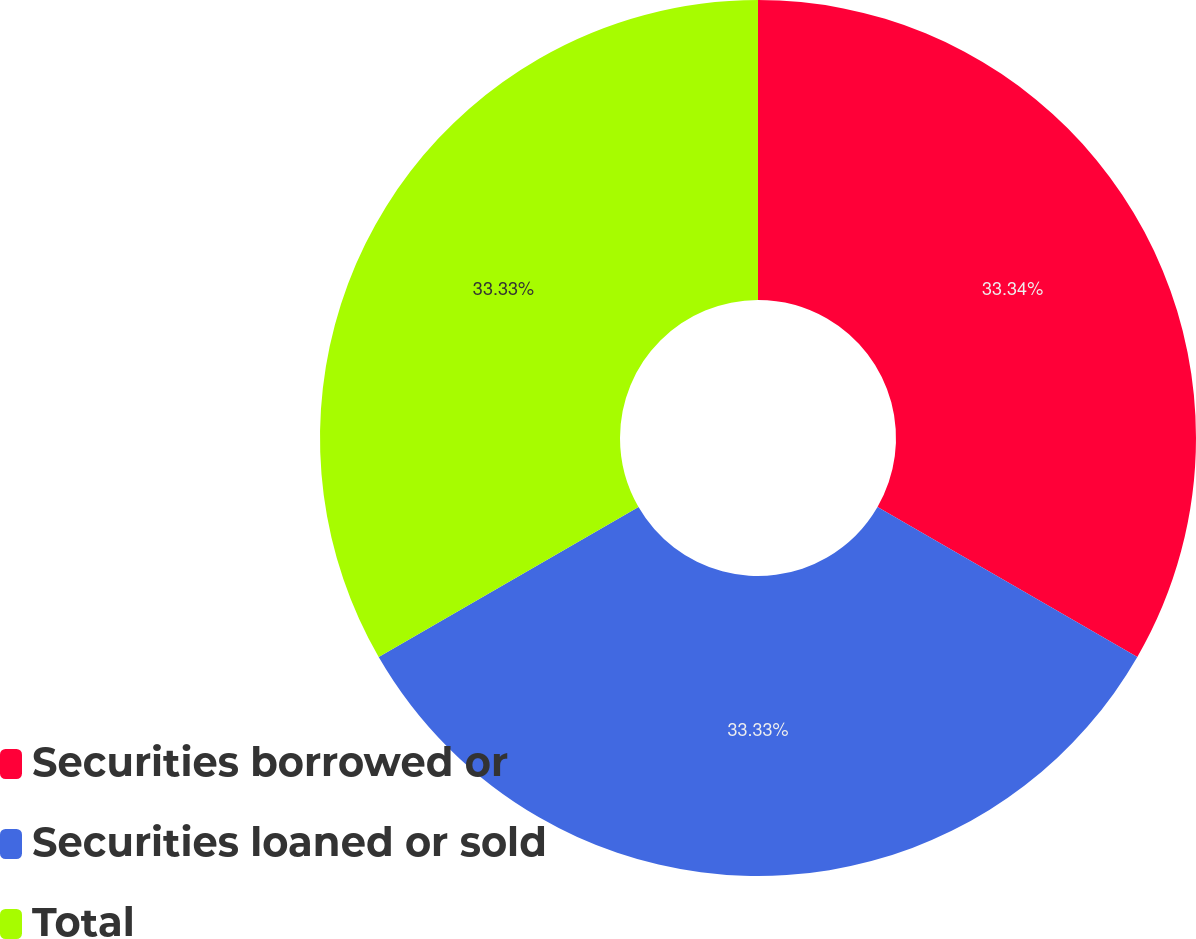Convert chart to OTSL. <chart><loc_0><loc_0><loc_500><loc_500><pie_chart><fcel>Securities borrowed or<fcel>Securities loaned or sold<fcel>Total<nl><fcel>33.33%<fcel>33.33%<fcel>33.33%<nl></chart> 